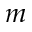Convert formula to latex. <formula><loc_0><loc_0><loc_500><loc_500>m</formula> 